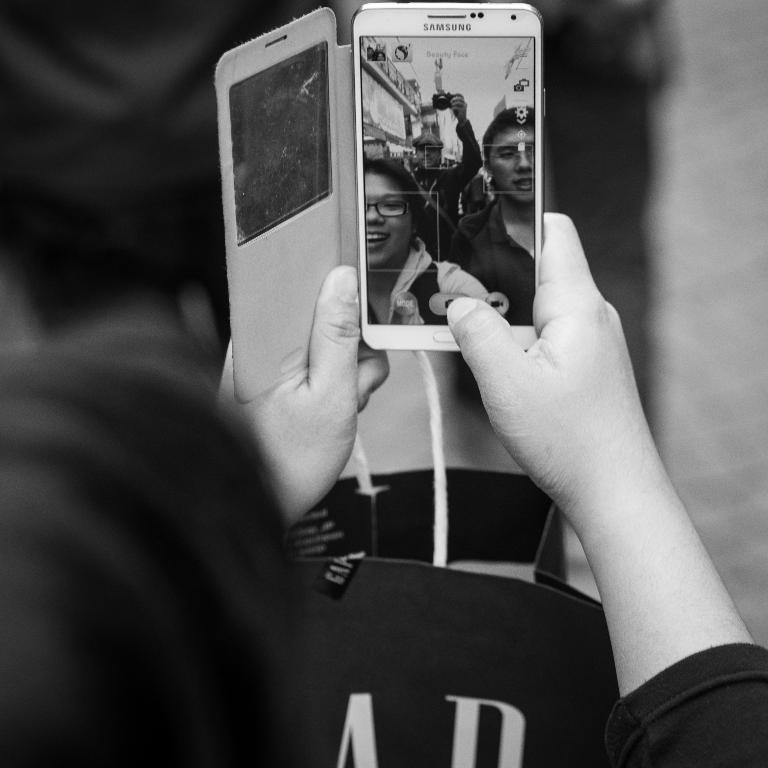What brand is the phone?
Ensure brevity in your answer.  Samsung. 